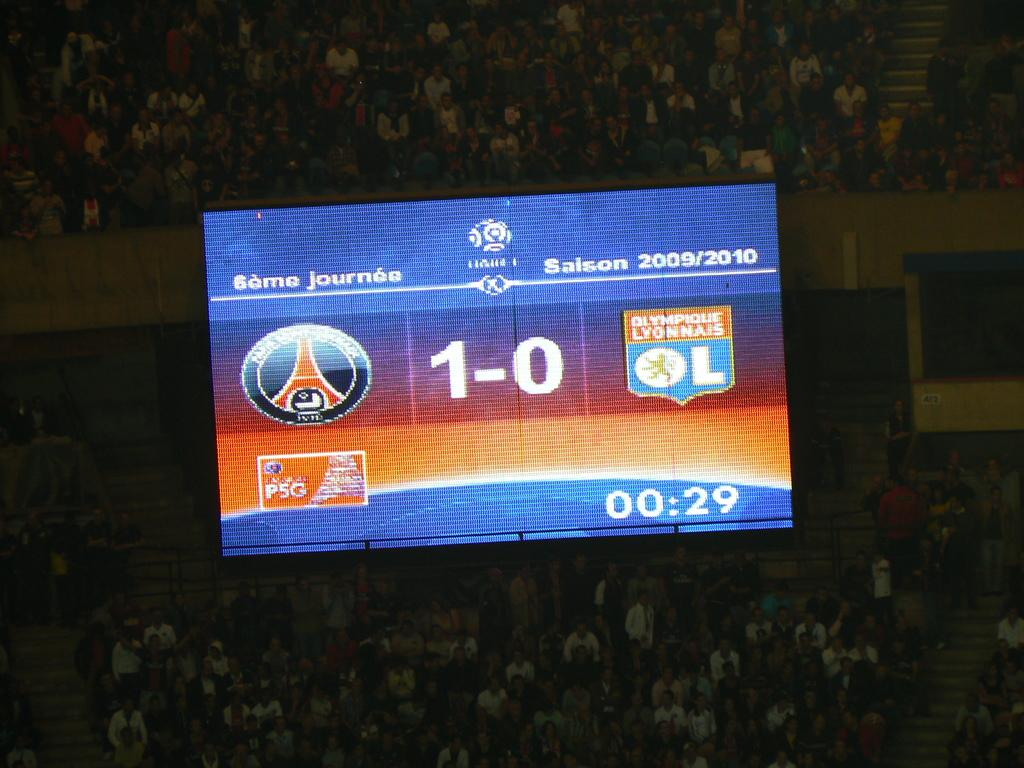<image>
Create a compact narrative representing the image presented. The time displayed on the screen is 00:29. 